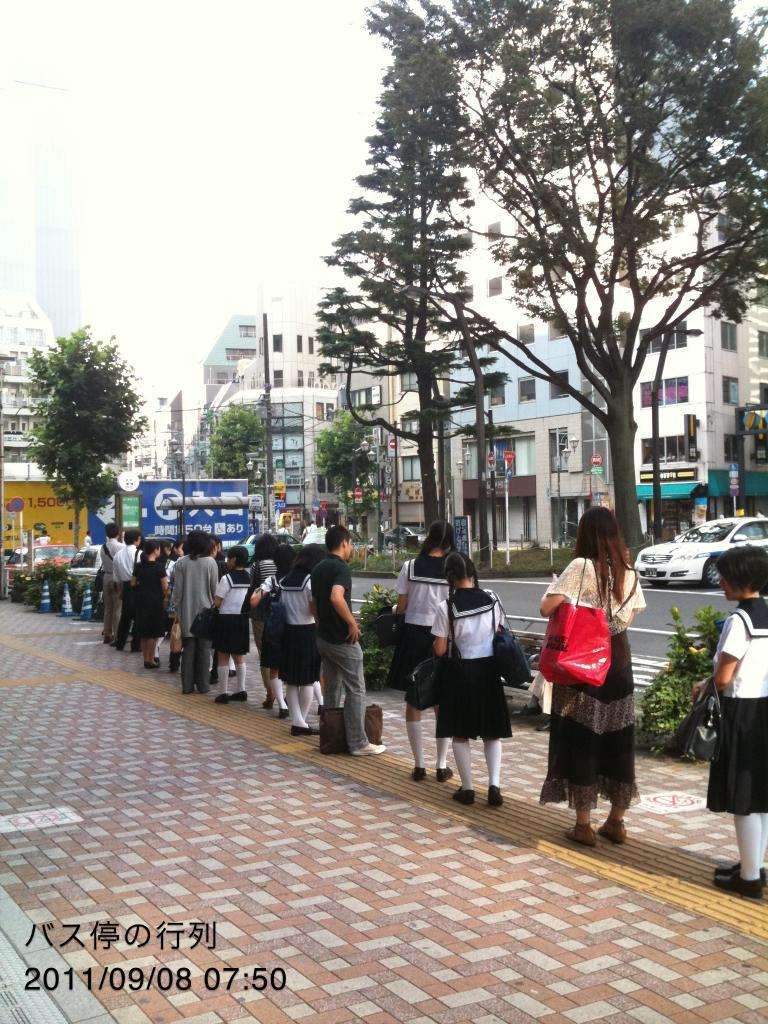How many people can be seen in the image? There are people in the image, but the exact number is not specified. What are some people wearing in the image? Some people are wearing bags in the image. What type of natural elements are present in the image? There are trees in the image. What type of man-made structures are present in the image? There are buildings in the image. What architectural features can be seen in the image? There are windows and poles in the image. What type of signage is present in the image? There are boards and sign boards in the image. What type of transportation is visible in the image? There are vehicles on the road in the image. What is the color of the sky in the image? The sky is white in color. How many eggs are visible on the sidewalk in the image? There are no eggs or sidewalks present in the image. 